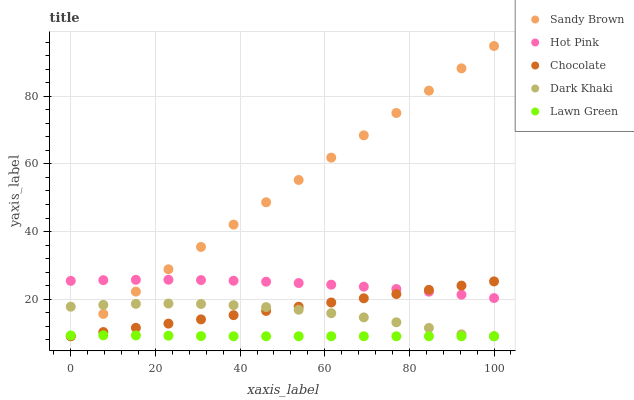Does Lawn Green have the minimum area under the curve?
Answer yes or no. Yes. Does Sandy Brown have the maximum area under the curve?
Answer yes or no. Yes. Does Hot Pink have the minimum area under the curve?
Answer yes or no. No. Does Hot Pink have the maximum area under the curve?
Answer yes or no. No. Is Chocolate the smoothest?
Answer yes or no. Yes. Is Dark Khaki the roughest?
Answer yes or no. Yes. Is Lawn Green the smoothest?
Answer yes or no. No. Is Lawn Green the roughest?
Answer yes or no. No. Does Dark Khaki have the lowest value?
Answer yes or no. Yes. Does Hot Pink have the lowest value?
Answer yes or no. No. Does Sandy Brown have the highest value?
Answer yes or no. Yes. Does Hot Pink have the highest value?
Answer yes or no. No. Is Dark Khaki less than Hot Pink?
Answer yes or no. Yes. Is Hot Pink greater than Dark Khaki?
Answer yes or no. Yes. Does Lawn Green intersect Dark Khaki?
Answer yes or no. Yes. Is Lawn Green less than Dark Khaki?
Answer yes or no. No. Is Lawn Green greater than Dark Khaki?
Answer yes or no. No. Does Dark Khaki intersect Hot Pink?
Answer yes or no. No. 